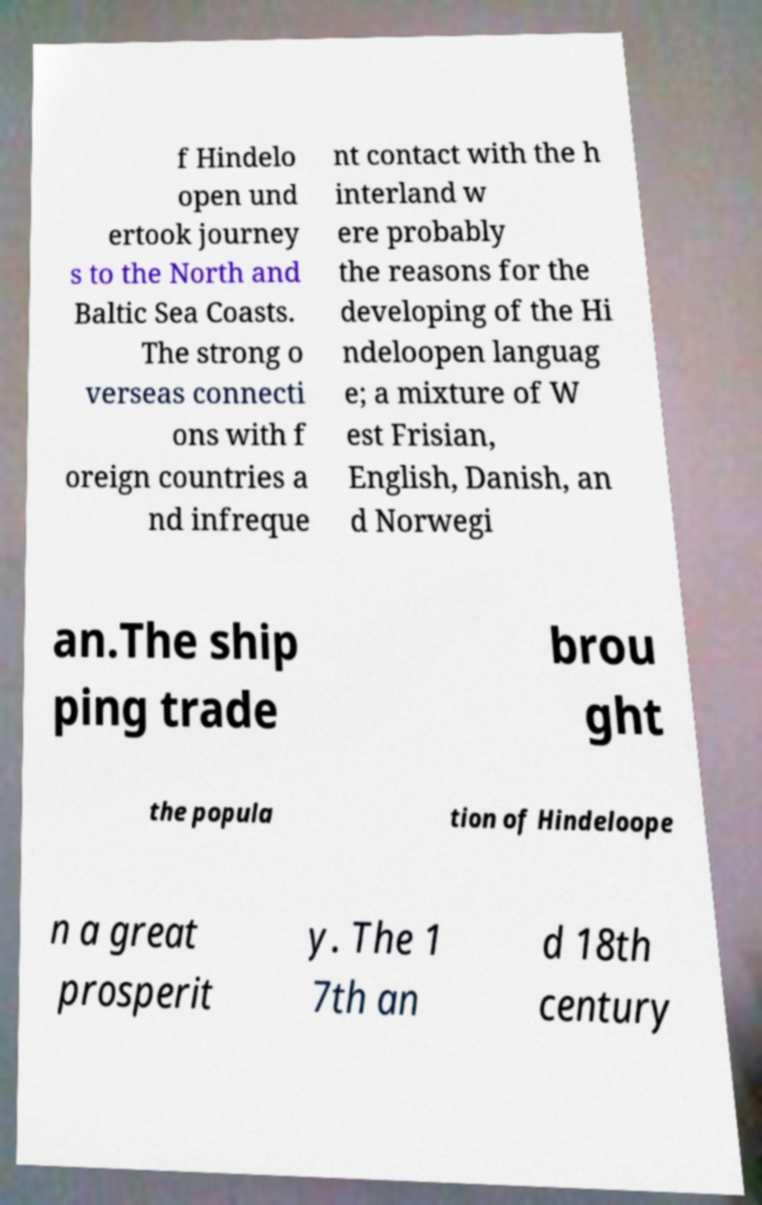For documentation purposes, I need the text within this image transcribed. Could you provide that? f Hindelo open und ertook journey s to the North and Baltic Sea Coasts. The strong o verseas connecti ons with f oreign countries a nd infreque nt contact with the h interland w ere probably the reasons for the developing of the Hi ndeloopen languag e; a mixture of W est Frisian, English, Danish, an d Norwegi an.The ship ping trade brou ght the popula tion of Hindeloope n a great prosperit y. The 1 7th an d 18th century 